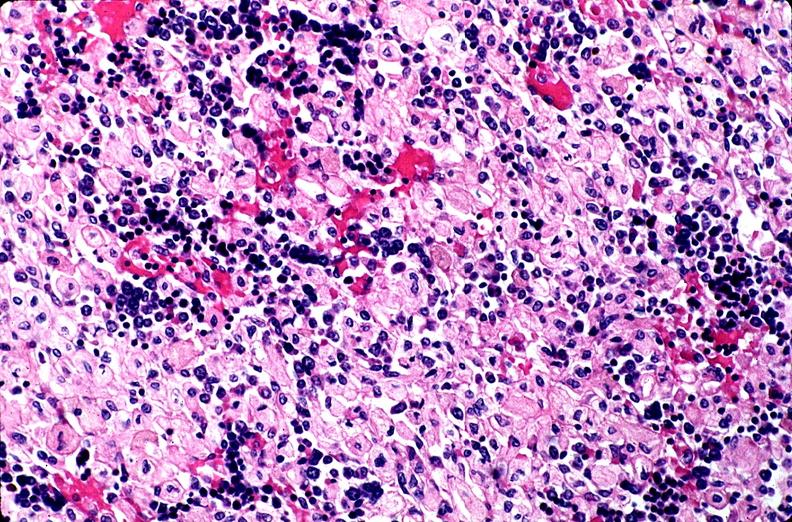does nipple duplication show gaucher disease?
Answer the question using a single word or phrase. No 